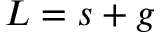<formula> <loc_0><loc_0><loc_500><loc_500>L = s + g</formula> 